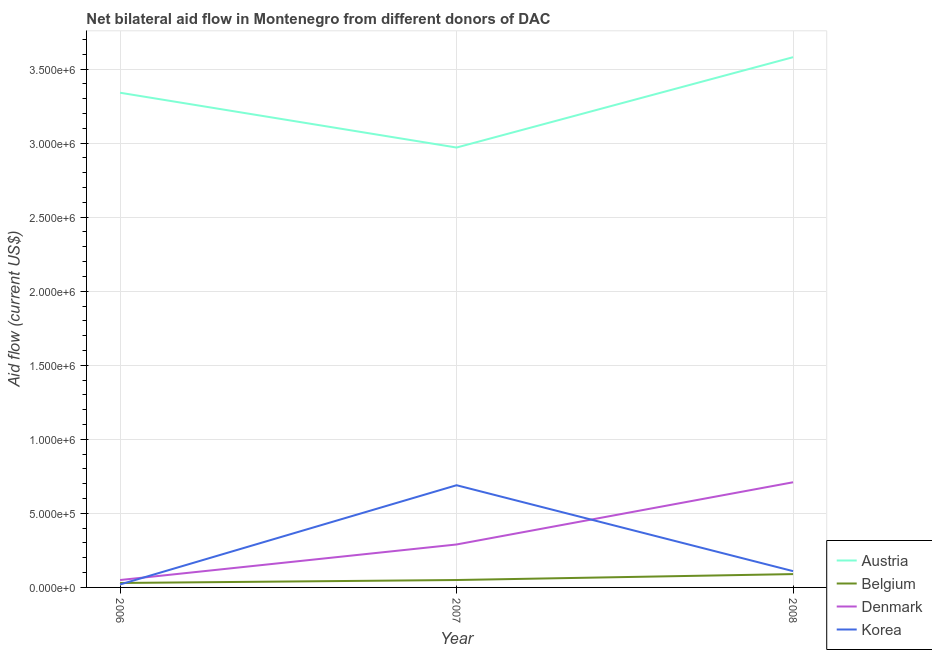Does the line corresponding to amount of aid given by belgium intersect with the line corresponding to amount of aid given by denmark?
Make the answer very short. No. Is the number of lines equal to the number of legend labels?
Keep it short and to the point. Yes. What is the amount of aid given by korea in 2006?
Provide a short and direct response. 2.00e+04. Across all years, what is the maximum amount of aid given by denmark?
Keep it short and to the point. 7.10e+05. Across all years, what is the minimum amount of aid given by austria?
Keep it short and to the point. 2.97e+06. In which year was the amount of aid given by korea minimum?
Your answer should be very brief. 2006. What is the total amount of aid given by belgium in the graph?
Your response must be concise. 1.70e+05. What is the difference between the amount of aid given by korea in 2006 and that in 2007?
Ensure brevity in your answer.  -6.70e+05. What is the difference between the amount of aid given by belgium in 2007 and the amount of aid given by denmark in 2006?
Offer a very short reply. 0. What is the average amount of aid given by belgium per year?
Give a very brief answer. 5.67e+04. In the year 2006, what is the difference between the amount of aid given by denmark and amount of aid given by belgium?
Your answer should be very brief. 2.00e+04. What is the ratio of the amount of aid given by belgium in 2007 to that in 2008?
Your answer should be very brief. 0.56. Is the amount of aid given by korea in 2006 less than that in 2007?
Ensure brevity in your answer.  Yes. What is the difference between the highest and the second highest amount of aid given by austria?
Ensure brevity in your answer.  2.40e+05. What is the difference between the highest and the lowest amount of aid given by austria?
Your answer should be compact. 6.10e+05. In how many years, is the amount of aid given by korea greater than the average amount of aid given by korea taken over all years?
Your response must be concise. 1. Is it the case that in every year, the sum of the amount of aid given by korea and amount of aid given by austria is greater than the sum of amount of aid given by belgium and amount of aid given by denmark?
Offer a very short reply. Yes. Is it the case that in every year, the sum of the amount of aid given by austria and amount of aid given by belgium is greater than the amount of aid given by denmark?
Offer a terse response. Yes. Does the amount of aid given by denmark monotonically increase over the years?
Give a very brief answer. Yes. Is the amount of aid given by austria strictly greater than the amount of aid given by korea over the years?
Ensure brevity in your answer.  Yes. Is the amount of aid given by denmark strictly less than the amount of aid given by belgium over the years?
Your answer should be compact. No. What is the difference between two consecutive major ticks on the Y-axis?
Ensure brevity in your answer.  5.00e+05. Does the graph contain any zero values?
Your response must be concise. No. Where does the legend appear in the graph?
Keep it short and to the point. Bottom right. How many legend labels are there?
Offer a very short reply. 4. How are the legend labels stacked?
Provide a short and direct response. Vertical. What is the title of the graph?
Ensure brevity in your answer.  Net bilateral aid flow in Montenegro from different donors of DAC. What is the label or title of the X-axis?
Your answer should be compact. Year. What is the label or title of the Y-axis?
Offer a terse response. Aid flow (current US$). What is the Aid flow (current US$) in Austria in 2006?
Provide a succinct answer. 3.34e+06. What is the Aid flow (current US$) of Denmark in 2006?
Offer a very short reply. 5.00e+04. What is the Aid flow (current US$) of Austria in 2007?
Make the answer very short. 2.97e+06. What is the Aid flow (current US$) of Denmark in 2007?
Make the answer very short. 2.90e+05. What is the Aid flow (current US$) in Korea in 2007?
Ensure brevity in your answer.  6.90e+05. What is the Aid flow (current US$) of Austria in 2008?
Offer a very short reply. 3.58e+06. What is the Aid flow (current US$) in Belgium in 2008?
Your response must be concise. 9.00e+04. What is the Aid flow (current US$) in Denmark in 2008?
Your response must be concise. 7.10e+05. Across all years, what is the maximum Aid flow (current US$) of Austria?
Keep it short and to the point. 3.58e+06. Across all years, what is the maximum Aid flow (current US$) of Denmark?
Your answer should be very brief. 7.10e+05. Across all years, what is the maximum Aid flow (current US$) of Korea?
Keep it short and to the point. 6.90e+05. Across all years, what is the minimum Aid flow (current US$) in Austria?
Ensure brevity in your answer.  2.97e+06. What is the total Aid flow (current US$) of Austria in the graph?
Offer a terse response. 9.89e+06. What is the total Aid flow (current US$) of Belgium in the graph?
Your answer should be compact. 1.70e+05. What is the total Aid flow (current US$) of Denmark in the graph?
Your response must be concise. 1.05e+06. What is the total Aid flow (current US$) in Korea in the graph?
Your response must be concise. 8.20e+05. What is the difference between the Aid flow (current US$) of Denmark in 2006 and that in 2007?
Your answer should be very brief. -2.40e+05. What is the difference between the Aid flow (current US$) in Korea in 2006 and that in 2007?
Give a very brief answer. -6.70e+05. What is the difference between the Aid flow (current US$) of Austria in 2006 and that in 2008?
Offer a very short reply. -2.40e+05. What is the difference between the Aid flow (current US$) in Denmark in 2006 and that in 2008?
Your response must be concise. -6.60e+05. What is the difference between the Aid flow (current US$) in Austria in 2007 and that in 2008?
Keep it short and to the point. -6.10e+05. What is the difference between the Aid flow (current US$) in Belgium in 2007 and that in 2008?
Your answer should be compact. -4.00e+04. What is the difference between the Aid flow (current US$) of Denmark in 2007 and that in 2008?
Keep it short and to the point. -4.20e+05. What is the difference between the Aid flow (current US$) in Korea in 2007 and that in 2008?
Ensure brevity in your answer.  5.80e+05. What is the difference between the Aid flow (current US$) of Austria in 2006 and the Aid flow (current US$) of Belgium in 2007?
Make the answer very short. 3.29e+06. What is the difference between the Aid flow (current US$) of Austria in 2006 and the Aid flow (current US$) of Denmark in 2007?
Make the answer very short. 3.05e+06. What is the difference between the Aid flow (current US$) in Austria in 2006 and the Aid flow (current US$) in Korea in 2007?
Offer a very short reply. 2.65e+06. What is the difference between the Aid flow (current US$) in Belgium in 2006 and the Aid flow (current US$) in Denmark in 2007?
Your answer should be compact. -2.60e+05. What is the difference between the Aid flow (current US$) of Belgium in 2006 and the Aid flow (current US$) of Korea in 2007?
Your response must be concise. -6.60e+05. What is the difference between the Aid flow (current US$) of Denmark in 2006 and the Aid flow (current US$) of Korea in 2007?
Ensure brevity in your answer.  -6.40e+05. What is the difference between the Aid flow (current US$) of Austria in 2006 and the Aid flow (current US$) of Belgium in 2008?
Give a very brief answer. 3.25e+06. What is the difference between the Aid flow (current US$) in Austria in 2006 and the Aid flow (current US$) in Denmark in 2008?
Ensure brevity in your answer.  2.63e+06. What is the difference between the Aid flow (current US$) of Austria in 2006 and the Aid flow (current US$) of Korea in 2008?
Provide a short and direct response. 3.23e+06. What is the difference between the Aid flow (current US$) in Belgium in 2006 and the Aid flow (current US$) in Denmark in 2008?
Your response must be concise. -6.80e+05. What is the difference between the Aid flow (current US$) of Austria in 2007 and the Aid flow (current US$) of Belgium in 2008?
Make the answer very short. 2.88e+06. What is the difference between the Aid flow (current US$) of Austria in 2007 and the Aid flow (current US$) of Denmark in 2008?
Your response must be concise. 2.26e+06. What is the difference between the Aid flow (current US$) in Austria in 2007 and the Aid flow (current US$) in Korea in 2008?
Make the answer very short. 2.86e+06. What is the difference between the Aid flow (current US$) of Belgium in 2007 and the Aid flow (current US$) of Denmark in 2008?
Keep it short and to the point. -6.60e+05. What is the difference between the Aid flow (current US$) in Belgium in 2007 and the Aid flow (current US$) in Korea in 2008?
Offer a very short reply. -6.00e+04. What is the average Aid flow (current US$) of Austria per year?
Your answer should be very brief. 3.30e+06. What is the average Aid flow (current US$) in Belgium per year?
Your answer should be compact. 5.67e+04. What is the average Aid flow (current US$) in Denmark per year?
Offer a very short reply. 3.50e+05. What is the average Aid flow (current US$) in Korea per year?
Your answer should be very brief. 2.73e+05. In the year 2006, what is the difference between the Aid flow (current US$) in Austria and Aid flow (current US$) in Belgium?
Offer a terse response. 3.31e+06. In the year 2006, what is the difference between the Aid flow (current US$) in Austria and Aid flow (current US$) in Denmark?
Your answer should be compact. 3.29e+06. In the year 2006, what is the difference between the Aid flow (current US$) in Austria and Aid flow (current US$) in Korea?
Offer a very short reply. 3.32e+06. In the year 2006, what is the difference between the Aid flow (current US$) of Belgium and Aid flow (current US$) of Korea?
Offer a terse response. 10000. In the year 2006, what is the difference between the Aid flow (current US$) of Denmark and Aid flow (current US$) of Korea?
Offer a terse response. 3.00e+04. In the year 2007, what is the difference between the Aid flow (current US$) in Austria and Aid flow (current US$) in Belgium?
Offer a terse response. 2.92e+06. In the year 2007, what is the difference between the Aid flow (current US$) of Austria and Aid flow (current US$) of Denmark?
Your answer should be compact. 2.68e+06. In the year 2007, what is the difference between the Aid flow (current US$) in Austria and Aid flow (current US$) in Korea?
Provide a succinct answer. 2.28e+06. In the year 2007, what is the difference between the Aid flow (current US$) of Belgium and Aid flow (current US$) of Korea?
Keep it short and to the point. -6.40e+05. In the year 2007, what is the difference between the Aid flow (current US$) in Denmark and Aid flow (current US$) in Korea?
Keep it short and to the point. -4.00e+05. In the year 2008, what is the difference between the Aid flow (current US$) of Austria and Aid flow (current US$) of Belgium?
Provide a succinct answer. 3.49e+06. In the year 2008, what is the difference between the Aid flow (current US$) in Austria and Aid flow (current US$) in Denmark?
Offer a terse response. 2.87e+06. In the year 2008, what is the difference between the Aid flow (current US$) in Austria and Aid flow (current US$) in Korea?
Provide a succinct answer. 3.47e+06. In the year 2008, what is the difference between the Aid flow (current US$) in Belgium and Aid flow (current US$) in Denmark?
Your answer should be very brief. -6.20e+05. In the year 2008, what is the difference between the Aid flow (current US$) in Denmark and Aid flow (current US$) in Korea?
Your response must be concise. 6.00e+05. What is the ratio of the Aid flow (current US$) of Austria in 2006 to that in 2007?
Make the answer very short. 1.12. What is the ratio of the Aid flow (current US$) in Denmark in 2006 to that in 2007?
Offer a very short reply. 0.17. What is the ratio of the Aid flow (current US$) of Korea in 2006 to that in 2007?
Offer a very short reply. 0.03. What is the ratio of the Aid flow (current US$) in Austria in 2006 to that in 2008?
Give a very brief answer. 0.93. What is the ratio of the Aid flow (current US$) in Belgium in 2006 to that in 2008?
Offer a terse response. 0.33. What is the ratio of the Aid flow (current US$) of Denmark in 2006 to that in 2008?
Your answer should be compact. 0.07. What is the ratio of the Aid flow (current US$) in Korea in 2006 to that in 2008?
Your answer should be very brief. 0.18. What is the ratio of the Aid flow (current US$) of Austria in 2007 to that in 2008?
Give a very brief answer. 0.83. What is the ratio of the Aid flow (current US$) of Belgium in 2007 to that in 2008?
Make the answer very short. 0.56. What is the ratio of the Aid flow (current US$) of Denmark in 2007 to that in 2008?
Your response must be concise. 0.41. What is the ratio of the Aid flow (current US$) in Korea in 2007 to that in 2008?
Your answer should be compact. 6.27. What is the difference between the highest and the second highest Aid flow (current US$) of Austria?
Offer a terse response. 2.40e+05. What is the difference between the highest and the second highest Aid flow (current US$) in Denmark?
Keep it short and to the point. 4.20e+05. What is the difference between the highest and the second highest Aid flow (current US$) in Korea?
Your response must be concise. 5.80e+05. What is the difference between the highest and the lowest Aid flow (current US$) in Belgium?
Your response must be concise. 6.00e+04. What is the difference between the highest and the lowest Aid flow (current US$) of Korea?
Make the answer very short. 6.70e+05. 